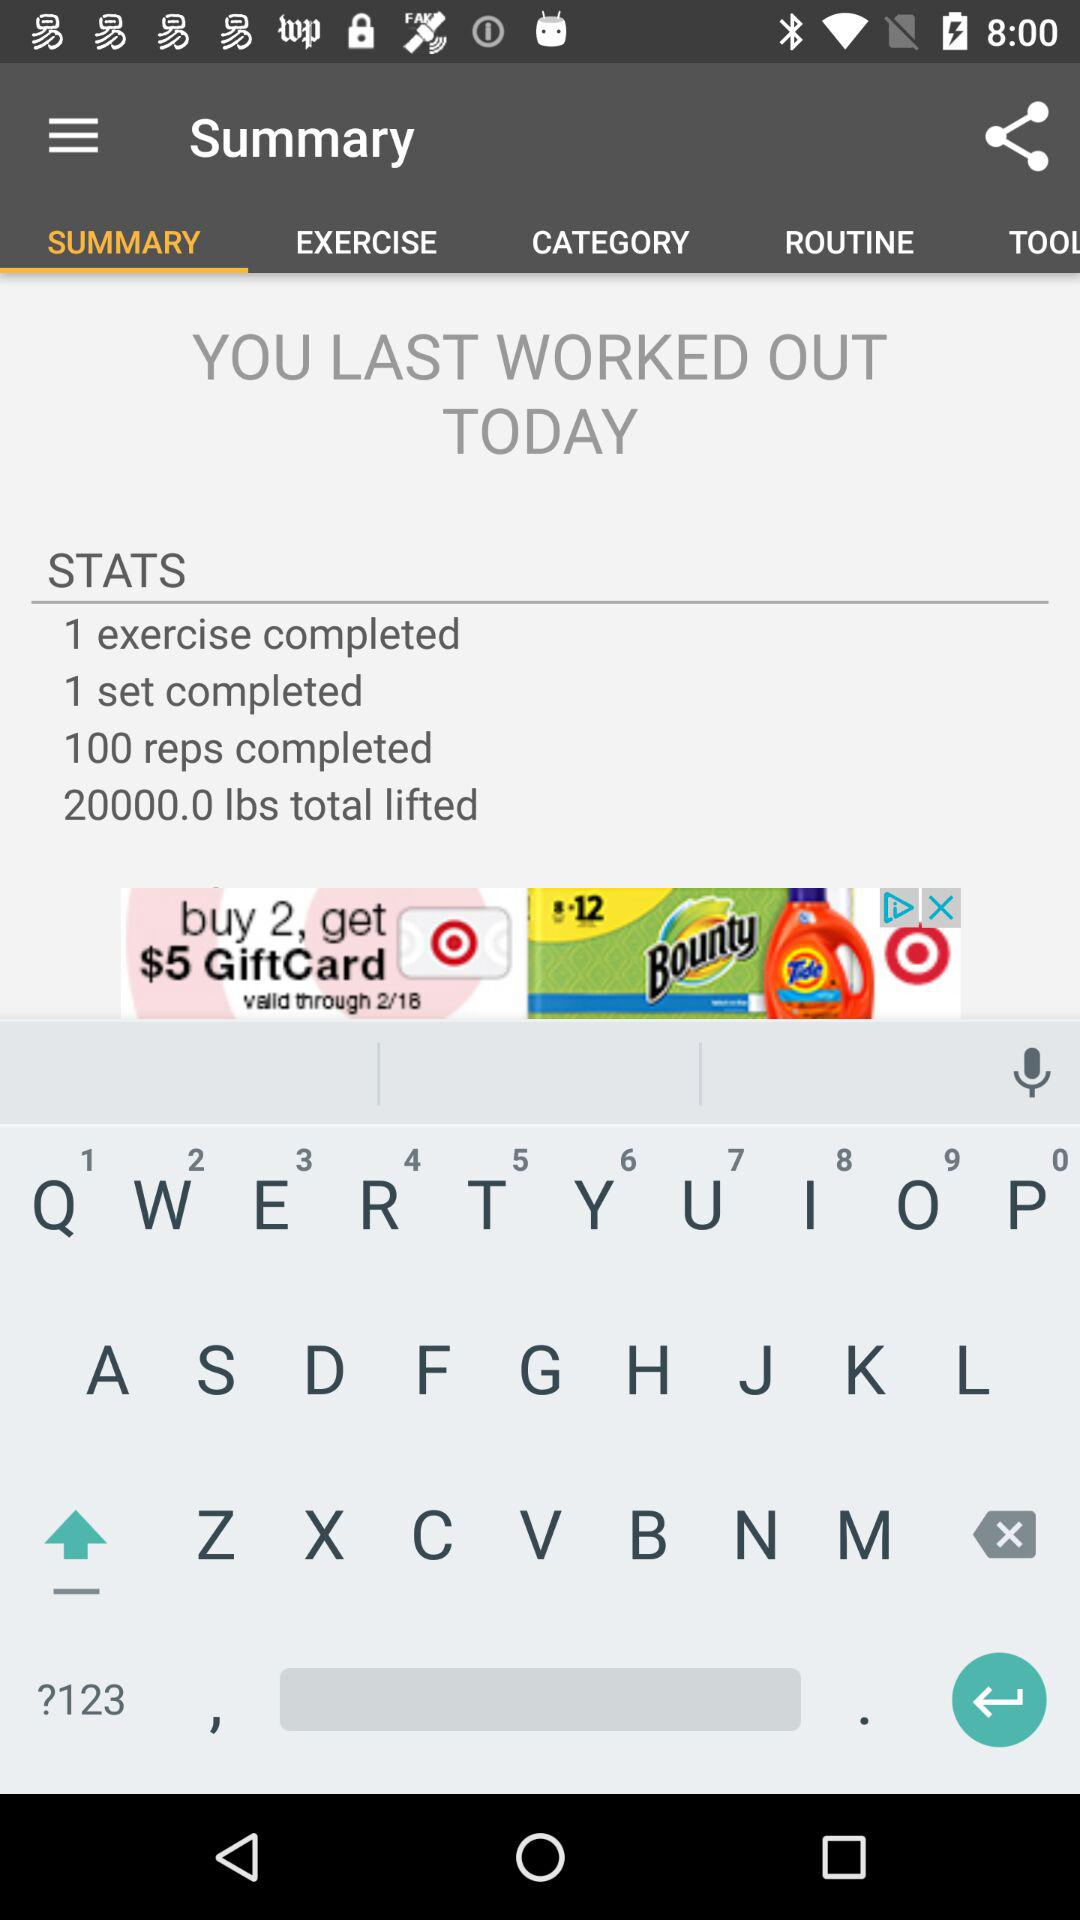How many more pounds have been lifted than exercises completed?
Answer the question using a single word or phrase. 19999.0 